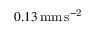<formula> <loc_0><loc_0><loc_500><loc_500>0 . 1 3 \, m m \, s ^ { - 2 }</formula> 